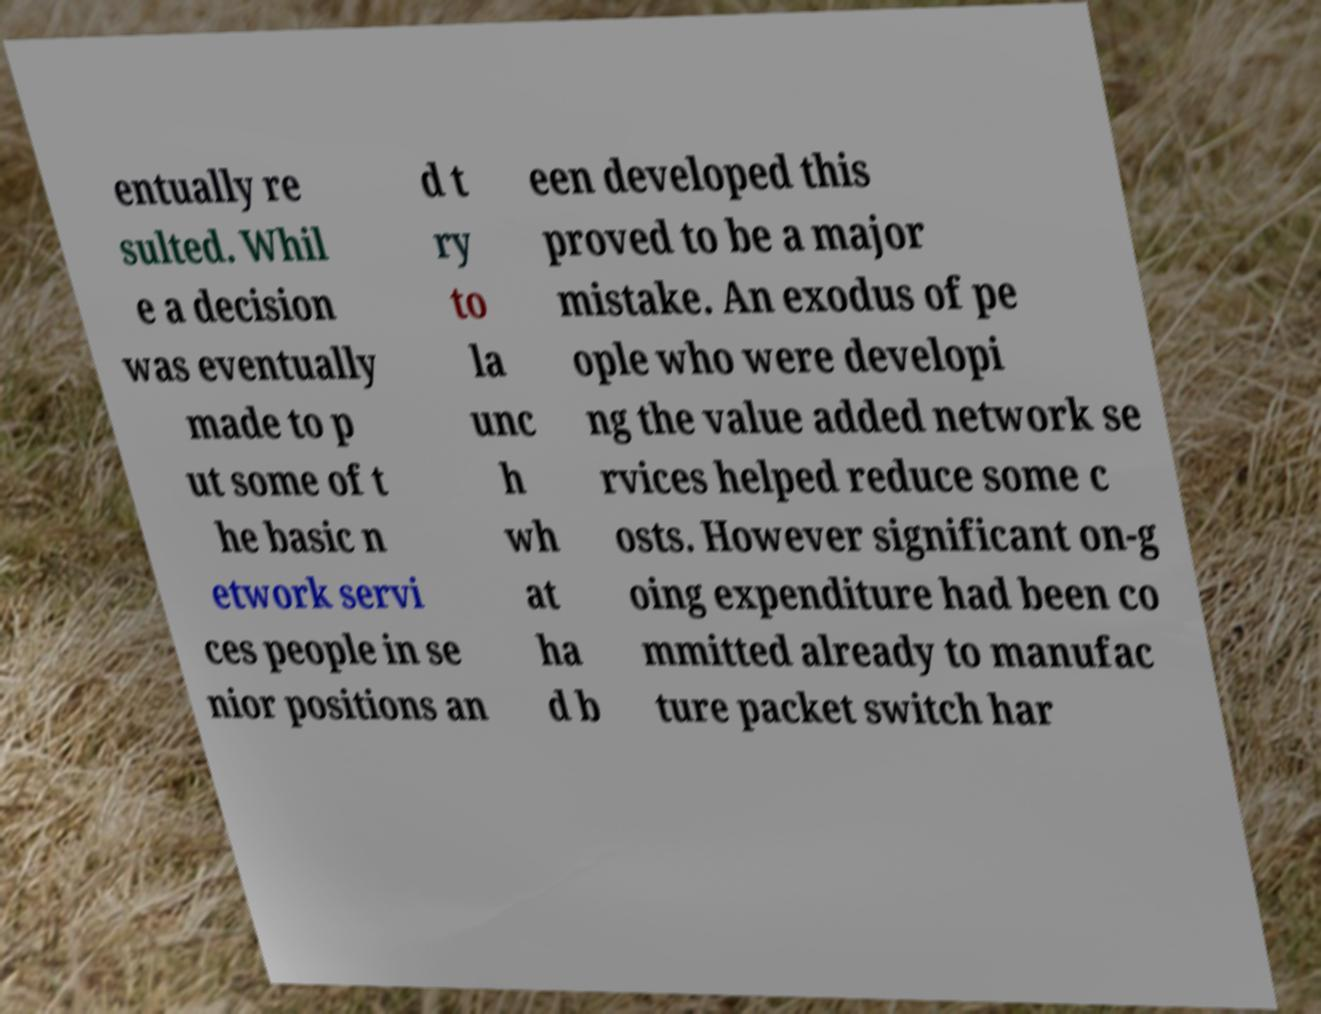Can you read and provide the text displayed in the image?This photo seems to have some interesting text. Can you extract and type it out for me? entually re sulted. Whil e a decision was eventually made to p ut some of t he basic n etwork servi ces people in se nior positions an d t ry to la unc h wh at ha d b een developed this proved to be a major mistake. An exodus of pe ople who were developi ng the value added network se rvices helped reduce some c osts. However significant on-g oing expenditure had been co mmitted already to manufac ture packet switch har 